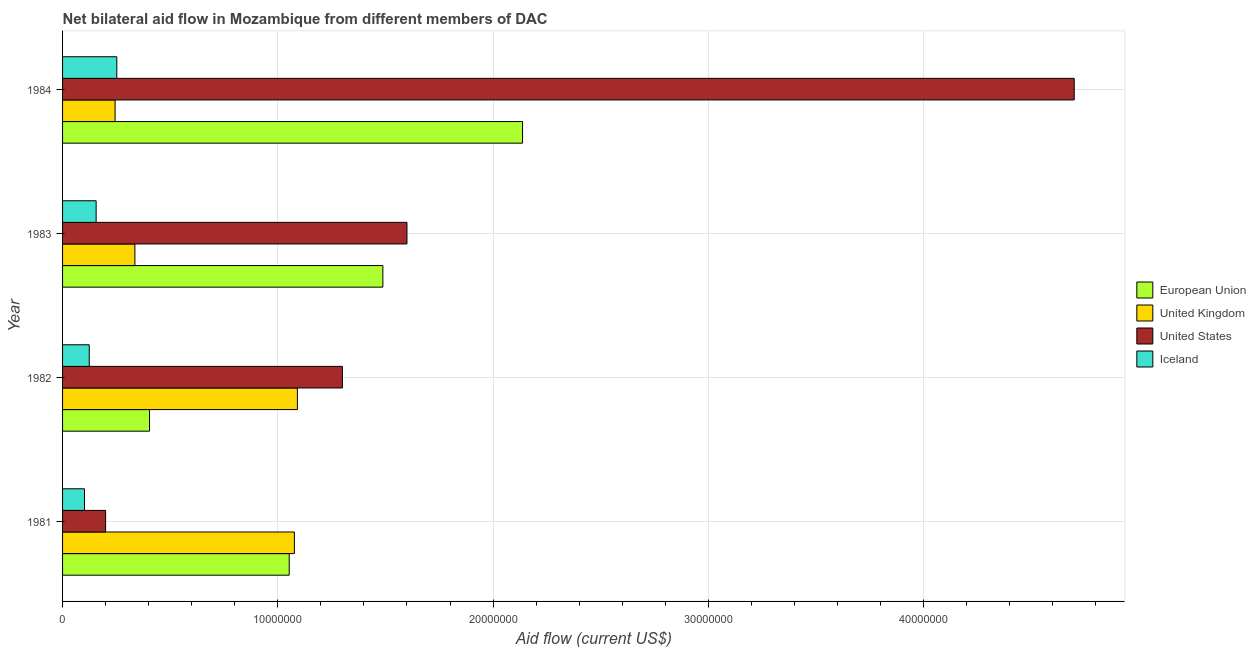How many different coloured bars are there?
Make the answer very short. 4. How many bars are there on the 2nd tick from the top?
Provide a succinct answer. 4. How many bars are there on the 3rd tick from the bottom?
Your response must be concise. 4. What is the amount of aid given by uk in 1984?
Your response must be concise. 2.44e+06. Across all years, what is the maximum amount of aid given by iceland?
Provide a short and direct response. 2.52e+06. Across all years, what is the minimum amount of aid given by us?
Your response must be concise. 2.00e+06. In which year was the amount of aid given by iceland maximum?
Make the answer very short. 1984. What is the total amount of aid given by iceland in the graph?
Provide a succinct answer. 6.34e+06. What is the difference between the amount of aid given by eu in 1981 and that in 1982?
Give a very brief answer. 6.49e+06. What is the difference between the amount of aid given by iceland in 1982 and the amount of aid given by us in 1981?
Make the answer very short. -7.60e+05. What is the average amount of aid given by uk per year?
Offer a very short reply. 6.87e+06. In the year 1983, what is the difference between the amount of aid given by eu and amount of aid given by iceland?
Offer a terse response. 1.33e+07. What is the ratio of the amount of aid given by eu in 1983 to that in 1984?
Give a very brief answer. 0.7. What is the difference between the highest and the second highest amount of aid given by uk?
Keep it short and to the point. 1.40e+05. What is the difference between the highest and the lowest amount of aid given by eu?
Make the answer very short. 1.73e+07. In how many years, is the amount of aid given by uk greater than the average amount of aid given by uk taken over all years?
Your response must be concise. 2. Is the sum of the amount of aid given by eu in 1983 and 1984 greater than the maximum amount of aid given by us across all years?
Give a very brief answer. No. Is it the case that in every year, the sum of the amount of aid given by uk and amount of aid given by eu is greater than the sum of amount of aid given by iceland and amount of aid given by us?
Make the answer very short. No. What does the 3rd bar from the top in 1983 represents?
Make the answer very short. United Kingdom. Is it the case that in every year, the sum of the amount of aid given by eu and amount of aid given by uk is greater than the amount of aid given by us?
Offer a terse response. No. Are all the bars in the graph horizontal?
Make the answer very short. Yes. Are the values on the major ticks of X-axis written in scientific E-notation?
Provide a short and direct response. No. Does the graph contain any zero values?
Provide a succinct answer. No. Does the graph contain grids?
Ensure brevity in your answer.  Yes. How many legend labels are there?
Ensure brevity in your answer.  4. How are the legend labels stacked?
Make the answer very short. Vertical. What is the title of the graph?
Ensure brevity in your answer.  Net bilateral aid flow in Mozambique from different members of DAC. What is the label or title of the X-axis?
Provide a short and direct response. Aid flow (current US$). What is the label or title of the Y-axis?
Offer a very short reply. Year. What is the Aid flow (current US$) in European Union in 1981?
Ensure brevity in your answer.  1.05e+07. What is the Aid flow (current US$) in United Kingdom in 1981?
Your answer should be compact. 1.08e+07. What is the Aid flow (current US$) in Iceland in 1981?
Offer a very short reply. 1.02e+06. What is the Aid flow (current US$) in European Union in 1982?
Provide a short and direct response. 4.04e+06. What is the Aid flow (current US$) in United Kingdom in 1982?
Your answer should be very brief. 1.09e+07. What is the Aid flow (current US$) in United States in 1982?
Provide a short and direct response. 1.30e+07. What is the Aid flow (current US$) of Iceland in 1982?
Offer a very short reply. 1.24e+06. What is the Aid flow (current US$) of European Union in 1983?
Provide a succinct answer. 1.49e+07. What is the Aid flow (current US$) in United Kingdom in 1983?
Make the answer very short. 3.36e+06. What is the Aid flow (current US$) of United States in 1983?
Your answer should be very brief. 1.60e+07. What is the Aid flow (current US$) of Iceland in 1983?
Keep it short and to the point. 1.56e+06. What is the Aid flow (current US$) in European Union in 1984?
Offer a very short reply. 2.14e+07. What is the Aid flow (current US$) in United Kingdom in 1984?
Ensure brevity in your answer.  2.44e+06. What is the Aid flow (current US$) in United States in 1984?
Ensure brevity in your answer.  4.70e+07. What is the Aid flow (current US$) in Iceland in 1984?
Ensure brevity in your answer.  2.52e+06. Across all years, what is the maximum Aid flow (current US$) in European Union?
Give a very brief answer. 2.14e+07. Across all years, what is the maximum Aid flow (current US$) in United Kingdom?
Give a very brief answer. 1.09e+07. Across all years, what is the maximum Aid flow (current US$) in United States?
Offer a very short reply. 4.70e+07. Across all years, what is the maximum Aid flow (current US$) of Iceland?
Your response must be concise. 2.52e+06. Across all years, what is the minimum Aid flow (current US$) in European Union?
Ensure brevity in your answer.  4.04e+06. Across all years, what is the minimum Aid flow (current US$) of United Kingdom?
Give a very brief answer. 2.44e+06. Across all years, what is the minimum Aid flow (current US$) of Iceland?
Offer a terse response. 1.02e+06. What is the total Aid flow (current US$) of European Union in the graph?
Your response must be concise. 5.08e+07. What is the total Aid flow (current US$) in United Kingdom in the graph?
Provide a succinct answer. 2.75e+07. What is the total Aid flow (current US$) in United States in the graph?
Make the answer very short. 7.80e+07. What is the total Aid flow (current US$) in Iceland in the graph?
Your answer should be very brief. 6.34e+06. What is the difference between the Aid flow (current US$) of European Union in 1981 and that in 1982?
Provide a succinct answer. 6.49e+06. What is the difference between the Aid flow (current US$) of United Kingdom in 1981 and that in 1982?
Ensure brevity in your answer.  -1.40e+05. What is the difference between the Aid flow (current US$) in United States in 1981 and that in 1982?
Keep it short and to the point. -1.10e+07. What is the difference between the Aid flow (current US$) in European Union in 1981 and that in 1983?
Your answer should be very brief. -4.35e+06. What is the difference between the Aid flow (current US$) of United Kingdom in 1981 and that in 1983?
Make the answer very short. 7.41e+06. What is the difference between the Aid flow (current US$) in United States in 1981 and that in 1983?
Offer a very short reply. -1.40e+07. What is the difference between the Aid flow (current US$) in Iceland in 1981 and that in 1983?
Keep it short and to the point. -5.40e+05. What is the difference between the Aid flow (current US$) of European Union in 1981 and that in 1984?
Provide a succinct answer. -1.08e+07. What is the difference between the Aid flow (current US$) of United Kingdom in 1981 and that in 1984?
Provide a short and direct response. 8.33e+06. What is the difference between the Aid flow (current US$) of United States in 1981 and that in 1984?
Provide a short and direct response. -4.50e+07. What is the difference between the Aid flow (current US$) in Iceland in 1981 and that in 1984?
Give a very brief answer. -1.50e+06. What is the difference between the Aid flow (current US$) of European Union in 1982 and that in 1983?
Offer a terse response. -1.08e+07. What is the difference between the Aid flow (current US$) of United Kingdom in 1982 and that in 1983?
Your answer should be very brief. 7.55e+06. What is the difference between the Aid flow (current US$) of Iceland in 1982 and that in 1983?
Provide a succinct answer. -3.20e+05. What is the difference between the Aid flow (current US$) in European Union in 1982 and that in 1984?
Your response must be concise. -1.73e+07. What is the difference between the Aid flow (current US$) in United Kingdom in 1982 and that in 1984?
Your answer should be very brief. 8.47e+06. What is the difference between the Aid flow (current US$) in United States in 1982 and that in 1984?
Ensure brevity in your answer.  -3.40e+07. What is the difference between the Aid flow (current US$) of Iceland in 1982 and that in 1984?
Your answer should be compact. -1.28e+06. What is the difference between the Aid flow (current US$) in European Union in 1983 and that in 1984?
Keep it short and to the point. -6.49e+06. What is the difference between the Aid flow (current US$) in United Kingdom in 1983 and that in 1984?
Offer a very short reply. 9.20e+05. What is the difference between the Aid flow (current US$) of United States in 1983 and that in 1984?
Give a very brief answer. -3.10e+07. What is the difference between the Aid flow (current US$) in Iceland in 1983 and that in 1984?
Provide a succinct answer. -9.60e+05. What is the difference between the Aid flow (current US$) of European Union in 1981 and the Aid flow (current US$) of United Kingdom in 1982?
Offer a very short reply. -3.80e+05. What is the difference between the Aid flow (current US$) in European Union in 1981 and the Aid flow (current US$) in United States in 1982?
Make the answer very short. -2.47e+06. What is the difference between the Aid flow (current US$) in European Union in 1981 and the Aid flow (current US$) in Iceland in 1982?
Ensure brevity in your answer.  9.29e+06. What is the difference between the Aid flow (current US$) of United Kingdom in 1981 and the Aid flow (current US$) of United States in 1982?
Provide a short and direct response. -2.23e+06. What is the difference between the Aid flow (current US$) in United Kingdom in 1981 and the Aid flow (current US$) in Iceland in 1982?
Provide a succinct answer. 9.53e+06. What is the difference between the Aid flow (current US$) of United States in 1981 and the Aid flow (current US$) of Iceland in 1982?
Your answer should be very brief. 7.60e+05. What is the difference between the Aid flow (current US$) of European Union in 1981 and the Aid flow (current US$) of United Kingdom in 1983?
Ensure brevity in your answer.  7.17e+06. What is the difference between the Aid flow (current US$) in European Union in 1981 and the Aid flow (current US$) in United States in 1983?
Keep it short and to the point. -5.47e+06. What is the difference between the Aid flow (current US$) in European Union in 1981 and the Aid flow (current US$) in Iceland in 1983?
Keep it short and to the point. 8.97e+06. What is the difference between the Aid flow (current US$) in United Kingdom in 1981 and the Aid flow (current US$) in United States in 1983?
Your answer should be very brief. -5.23e+06. What is the difference between the Aid flow (current US$) of United Kingdom in 1981 and the Aid flow (current US$) of Iceland in 1983?
Your answer should be very brief. 9.21e+06. What is the difference between the Aid flow (current US$) of United States in 1981 and the Aid flow (current US$) of Iceland in 1983?
Offer a very short reply. 4.40e+05. What is the difference between the Aid flow (current US$) in European Union in 1981 and the Aid flow (current US$) in United Kingdom in 1984?
Give a very brief answer. 8.09e+06. What is the difference between the Aid flow (current US$) in European Union in 1981 and the Aid flow (current US$) in United States in 1984?
Your answer should be compact. -3.65e+07. What is the difference between the Aid flow (current US$) in European Union in 1981 and the Aid flow (current US$) in Iceland in 1984?
Keep it short and to the point. 8.01e+06. What is the difference between the Aid flow (current US$) in United Kingdom in 1981 and the Aid flow (current US$) in United States in 1984?
Give a very brief answer. -3.62e+07. What is the difference between the Aid flow (current US$) in United Kingdom in 1981 and the Aid flow (current US$) in Iceland in 1984?
Keep it short and to the point. 8.25e+06. What is the difference between the Aid flow (current US$) in United States in 1981 and the Aid flow (current US$) in Iceland in 1984?
Give a very brief answer. -5.20e+05. What is the difference between the Aid flow (current US$) of European Union in 1982 and the Aid flow (current US$) of United Kingdom in 1983?
Keep it short and to the point. 6.80e+05. What is the difference between the Aid flow (current US$) in European Union in 1982 and the Aid flow (current US$) in United States in 1983?
Provide a succinct answer. -1.20e+07. What is the difference between the Aid flow (current US$) of European Union in 1982 and the Aid flow (current US$) of Iceland in 1983?
Your response must be concise. 2.48e+06. What is the difference between the Aid flow (current US$) of United Kingdom in 1982 and the Aid flow (current US$) of United States in 1983?
Ensure brevity in your answer.  -5.09e+06. What is the difference between the Aid flow (current US$) of United Kingdom in 1982 and the Aid flow (current US$) of Iceland in 1983?
Offer a very short reply. 9.35e+06. What is the difference between the Aid flow (current US$) in United States in 1982 and the Aid flow (current US$) in Iceland in 1983?
Offer a terse response. 1.14e+07. What is the difference between the Aid flow (current US$) in European Union in 1982 and the Aid flow (current US$) in United Kingdom in 1984?
Provide a succinct answer. 1.60e+06. What is the difference between the Aid flow (current US$) of European Union in 1982 and the Aid flow (current US$) of United States in 1984?
Provide a short and direct response. -4.30e+07. What is the difference between the Aid flow (current US$) in European Union in 1982 and the Aid flow (current US$) in Iceland in 1984?
Your answer should be compact. 1.52e+06. What is the difference between the Aid flow (current US$) of United Kingdom in 1982 and the Aid flow (current US$) of United States in 1984?
Give a very brief answer. -3.61e+07. What is the difference between the Aid flow (current US$) of United Kingdom in 1982 and the Aid flow (current US$) of Iceland in 1984?
Your answer should be compact. 8.39e+06. What is the difference between the Aid flow (current US$) in United States in 1982 and the Aid flow (current US$) in Iceland in 1984?
Keep it short and to the point. 1.05e+07. What is the difference between the Aid flow (current US$) in European Union in 1983 and the Aid flow (current US$) in United Kingdom in 1984?
Keep it short and to the point. 1.24e+07. What is the difference between the Aid flow (current US$) of European Union in 1983 and the Aid flow (current US$) of United States in 1984?
Your answer should be compact. -3.21e+07. What is the difference between the Aid flow (current US$) of European Union in 1983 and the Aid flow (current US$) of Iceland in 1984?
Keep it short and to the point. 1.24e+07. What is the difference between the Aid flow (current US$) in United Kingdom in 1983 and the Aid flow (current US$) in United States in 1984?
Your answer should be very brief. -4.36e+07. What is the difference between the Aid flow (current US$) of United Kingdom in 1983 and the Aid flow (current US$) of Iceland in 1984?
Your response must be concise. 8.40e+05. What is the difference between the Aid flow (current US$) in United States in 1983 and the Aid flow (current US$) in Iceland in 1984?
Keep it short and to the point. 1.35e+07. What is the average Aid flow (current US$) of European Union per year?
Make the answer very short. 1.27e+07. What is the average Aid flow (current US$) in United Kingdom per year?
Make the answer very short. 6.87e+06. What is the average Aid flow (current US$) of United States per year?
Keep it short and to the point. 1.95e+07. What is the average Aid flow (current US$) in Iceland per year?
Keep it short and to the point. 1.58e+06. In the year 1981, what is the difference between the Aid flow (current US$) of European Union and Aid flow (current US$) of United Kingdom?
Provide a short and direct response. -2.40e+05. In the year 1981, what is the difference between the Aid flow (current US$) in European Union and Aid flow (current US$) in United States?
Give a very brief answer. 8.53e+06. In the year 1981, what is the difference between the Aid flow (current US$) in European Union and Aid flow (current US$) in Iceland?
Ensure brevity in your answer.  9.51e+06. In the year 1981, what is the difference between the Aid flow (current US$) in United Kingdom and Aid flow (current US$) in United States?
Keep it short and to the point. 8.77e+06. In the year 1981, what is the difference between the Aid flow (current US$) in United Kingdom and Aid flow (current US$) in Iceland?
Give a very brief answer. 9.75e+06. In the year 1981, what is the difference between the Aid flow (current US$) in United States and Aid flow (current US$) in Iceland?
Offer a terse response. 9.80e+05. In the year 1982, what is the difference between the Aid flow (current US$) in European Union and Aid flow (current US$) in United Kingdom?
Give a very brief answer. -6.87e+06. In the year 1982, what is the difference between the Aid flow (current US$) in European Union and Aid flow (current US$) in United States?
Your response must be concise. -8.96e+06. In the year 1982, what is the difference between the Aid flow (current US$) in European Union and Aid flow (current US$) in Iceland?
Your answer should be very brief. 2.80e+06. In the year 1982, what is the difference between the Aid flow (current US$) of United Kingdom and Aid flow (current US$) of United States?
Keep it short and to the point. -2.09e+06. In the year 1982, what is the difference between the Aid flow (current US$) of United Kingdom and Aid flow (current US$) of Iceland?
Your answer should be compact. 9.67e+06. In the year 1982, what is the difference between the Aid flow (current US$) in United States and Aid flow (current US$) in Iceland?
Your response must be concise. 1.18e+07. In the year 1983, what is the difference between the Aid flow (current US$) of European Union and Aid flow (current US$) of United Kingdom?
Give a very brief answer. 1.15e+07. In the year 1983, what is the difference between the Aid flow (current US$) of European Union and Aid flow (current US$) of United States?
Keep it short and to the point. -1.12e+06. In the year 1983, what is the difference between the Aid flow (current US$) of European Union and Aid flow (current US$) of Iceland?
Provide a succinct answer. 1.33e+07. In the year 1983, what is the difference between the Aid flow (current US$) in United Kingdom and Aid flow (current US$) in United States?
Keep it short and to the point. -1.26e+07. In the year 1983, what is the difference between the Aid flow (current US$) of United Kingdom and Aid flow (current US$) of Iceland?
Offer a terse response. 1.80e+06. In the year 1983, what is the difference between the Aid flow (current US$) of United States and Aid flow (current US$) of Iceland?
Your answer should be very brief. 1.44e+07. In the year 1984, what is the difference between the Aid flow (current US$) of European Union and Aid flow (current US$) of United Kingdom?
Provide a short and direct response. 1.89e+07. In the year 1984, what is the difference between the Aid flow (current US$) of European Union and Aid flow (current US$) of United States?
Keep it short and to the point. -2.56e+07. In the year 1984, what is the difference between the Aid flow (current US$) in European Union and Aid flow (current US$) in Iceland?
Provide a short and direct response. 1.88e+07. In the year 1984, what is the difference between the Aid flow (current US$) in United Kingdom and Aid flow (current US$) in United States?
Ensure brevity in your answer.  -4.46e+07. In the year 1984, what is the difference between the Aid flow (current US$) in United States and Aid flow (current US$) in Iceland?
Give a very brief answer. 4.45e+07. What is the ratio of the Aid flow (current US$) in European Union in 1981 to that in 1982?
Offer a terse response. 2.61. What is the ratio of the Aid flow (current US$) in United Kingdom in 1981 to that in 1982?
Provide a short and direct response. 0.99. What is the ratio of the Aid flow (current US$) of United States in 1981 to that in 1982?
Offer a terse response. 0.15. What is the ratio of the Aid flow (current US$) of Iceland in 1981 to that in 1982?
Your answer should be compact. 0.82. What is the ratio of the Aid flow (current US$) of European Union in 1981 to that in 1983?
Your answer should be very brief. 0.71. What is the ratio of the Aid flow (current US$) of United Kingdom in 1981 to that in 1983?
Keep it short and to the point. 3.21. What is the ratio of the Aid flow (current US$) of United States in 1981 to that in 1983?
Ensure brevity in your answer.  0.12. What is the ratio of the Aid flow (current US$) in Iceland in 1981 to that in 1983?
Make the answer very short. 0.65. What is the ratio of the Aid flow (current US$) of European Union in 1981 to that in 1984?
Offer a very short reply. 0.49. What is the ratio of the Aid flow (current US$) of United Kingdom in 1981 to that in 1984?
Provide a short and direct response. 4.41. What is the ratio of the Aid flow (current US$) in United States in 1981 to that in 1984?
Your response must be concise. 0.04. What is the ratio of the Aid flow (current US$) in Iceland in 1981 to that in 1984?
Your answer should be very brief. 0.4. What is the ratio of the Aid flow (current US$) of European Union in 1982 to that in 1983?
Offer a very short reply. 0.27. What is the ratio of the Aid flow (current US$) of United Kingdom in 1982 to that in 1983?
Give a very brief answer. 3.25. What is the ratio of the Aid flow (current US$) in United States in 1982 to that in 1983?
Provide a short and direct response. 0.81. What is the ratio of the Aid flow (current US$) of Iceland in 1982 to that in 1983?
Make the answer very short. 0.79. What is the ratio of the Aid flow (current US$) in European Union in 1982 to that in 1984?
Provide a short and direct response. 0.19. What is the ratio of the Aid flow (current US$) of United Kingdom in 1982 to that in 1984?
Give a very brief answer. 4.47. What is the ratio of the Aid flow (current US$) in United States in 1982 to that in 1984?
Offer a very short reply. 0.28. What is the ratio of the Aid flow (current US$) of Iceland in 1982 to that in 1984?
Give a very brief answer. 0.49. What is the ratio of the Aid flow (current US$) of European Union in 1983 to that in 1984?
Provide a short and direct response. 0.7. What is the ratio of the Aid flow (current US$) in United Kingdom in 1983 to that in 1984?
Your answer should be very brief. 1.38. What is the ratio of the Aid flow (current US$) in United States in 1983 to that in 1984?
Your answer should be very brief. 0.34. What is the ratio of the Aid flow (current US$) in Iceland in 1983 to that in 1984?
Your answer should be very brief. 0.62. What is the difference between the highest and the second highest Aid flow (current US$) in European Union?
Provide a succinct answer. 6.49e+06. What is the difference between the highest and the second highest Aid flow (current US$) of United Kingdom?
Ensure brevity in your answer.  1.40e+05. What is the difference between the highest and the second highest Aid flow (current US$) in United States?
Your response must be concise. 3.10e+07. What is the difference between the highest and the second highest Aid flow (current US$) of Iceland?
Your answer should be very brief. 9.60e+05. What is the difference between the highest and the lowest Aid flow (current US$) of European Union?
Give a very brief answer. 1.73e+07. What is the difference between the highest and the lowest Aid flow (current US$) of United Kingdom?
Provide a short and direct response. 8.47e+06. What is the difference between the highest and the lowest Aid flow (current US$) of United States?
Make the answer very short. 4.50e+07. What is the difference between the highest and the lowest Aid flow (current US$) in Iceland?
Offer a very short reply. 1.50e+06. 